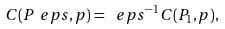<formula> <loc_0><loc_0><loc_500><loc_500>C ( P _ { \ } e p s , p ) = \ e p s ^ { - 1 } C ( P _ { 1 } , p ) ,</formula> 